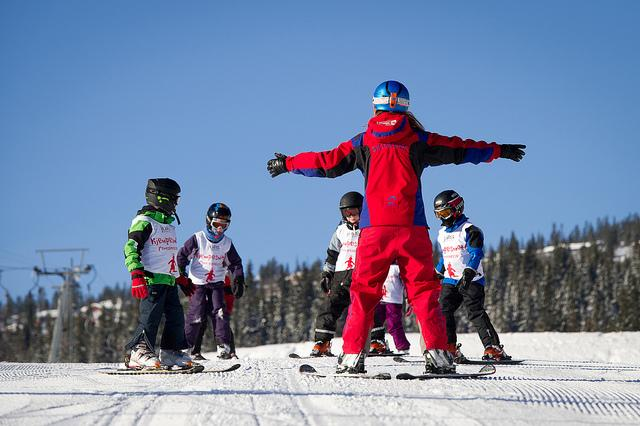What does the person in red provide?

Choices:
A) admonishments
B) snacks
C) ski lessons
D) grades ski lessons 